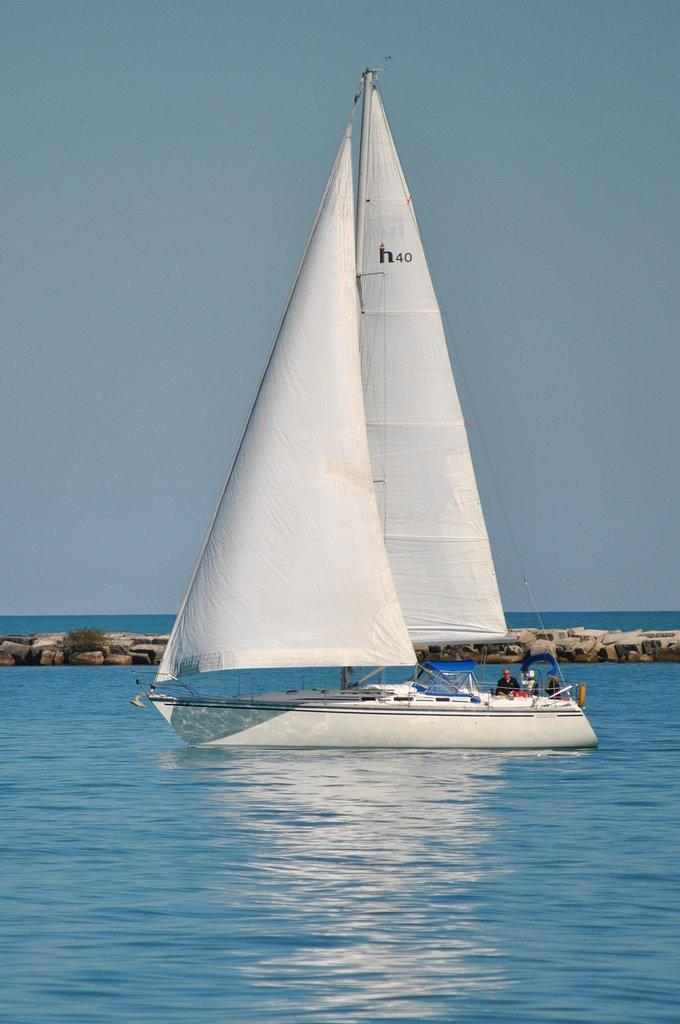What is the main subject of the image? The main subject of the image is a boat in the water. How many people are in the boat? There are three persons in the boat. What can be seen in the background of the image? Stones and the sky are visible in the background. Where might this image have been taken? The image may have been taken in the ocean, given the presence of water and the boat. What type of army equipment can be seen in the image? There is no army equipment present in the image; it features a boat with three people in the water. What holiday is being celebrated in the image? There is no indication of a holiday being celebrated in the image. 